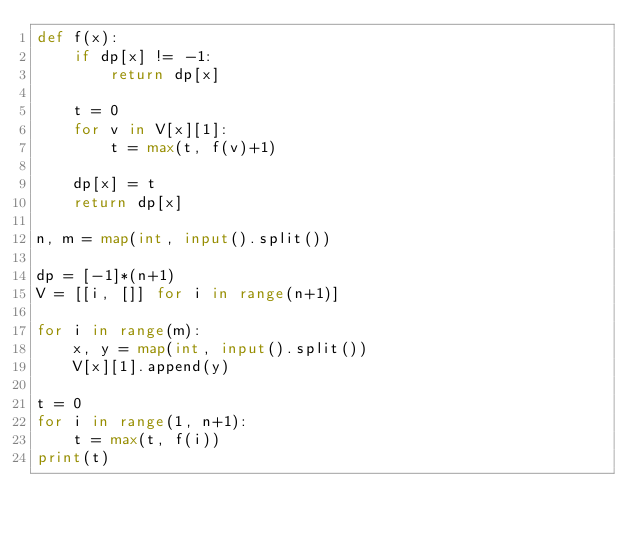<code> <loc_0><loc_0><loc_500><loc_500><_Python_>def f(x):
    if dp[x] != -1:
        return dp[x]

    t = 0
    for v in V[x][1]:
        t = max(t, f(v)+1)

    dp[x] = t
    return dp[x]

n, m = map(int, input().split())

dp = [-1]*(n+1)
V = [[i, []] for i in range(n+1)]

for i in range(m):
    x, y = map(int, input().split())
    V[x][1].append(y)

t = 0
for i in range(1, n+1):
    t = max(t, f(i))
print(t)
</code> 